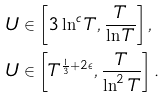Convert formula to latex. <formula><loc_0><loc_0><loc_500><loc_500>& U \in \left [ 3 \ln ^ { c } T , \frac { T } { \ln T } \right ] , \\ & U \in \left [ T ^ { \frac { 1 } { 3 } + 2 \epsilon } , \frac { T } { \ln ^ { 2 } T } \right ] .</formula> 